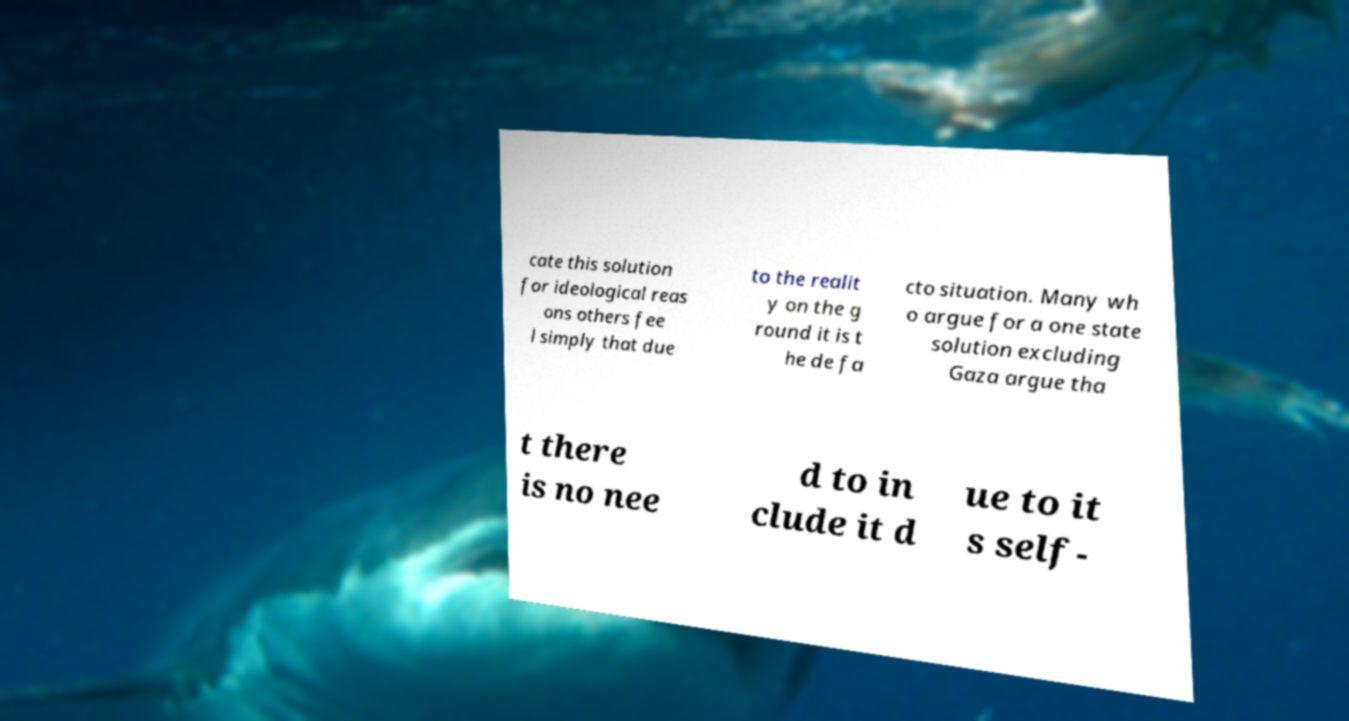There's text embedded in this image that I need extracted. Can you transcribe it verbatim? cate this solution for ideological reas ons others fee l simply that due to the realit y on the g round it is t he de fa cto situation. Many wh o argue for a one state solution excluding Gaza argue tha t there is no nee d to in clude it d ue to it s self- 